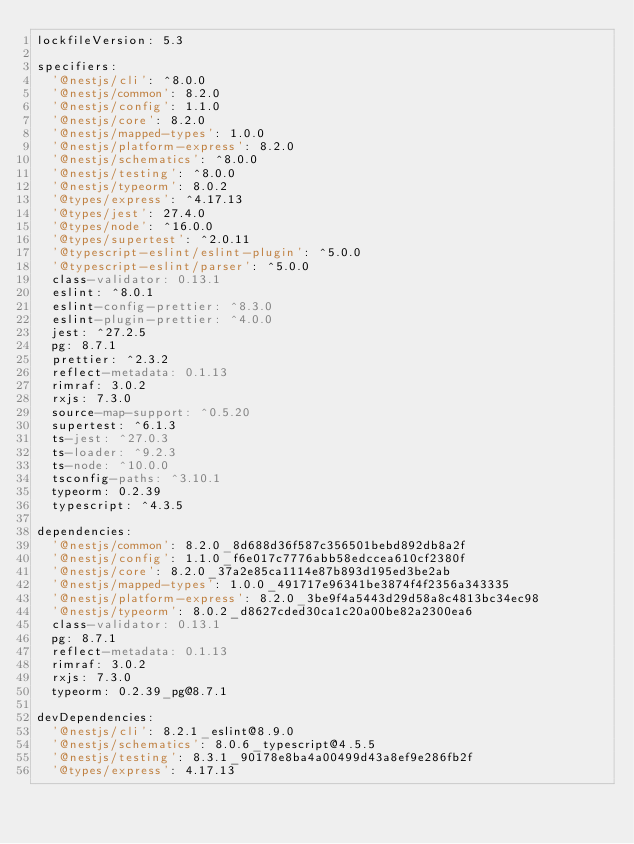<code> <loc_0><loc_0><loc_500><loc_500><_YAML_>lockfileVersion: 5.3

specifiers:
  '@nestjs/cli': ^8.0.0
  '@nestjs/common': 8.2.0
  '@nestjs/config': 1.1.0
  '@nestjs/core': 8.2.0
  '@nestjs/mapped-types': 1.0.0
  '@nestjs/platform-express': 8.2.0
  '@nestjs/schematics': ^8.0.0
  '@nestjs/testing': ^8.0.0
  '@nestjs/typeorm': 8.0.2
  '@types/express': ^4.17.13
  '@types/jest': 27.4.0
  '@types/node': ^16.0.0
  '@types/supertest': ^2.0.11
  '@typescript-eslint/eslint-plugin': ^5.0.0
  '@typescript-eslint/parser': ^5.0.0
  class-validator: 0.13.1
  eslint: ^8.0.1
  eslint-config-prettier: ^8.3.0
  eslint-plugin-prettier: ^4.0.0
  jest: ^27.2.5
  pg: 8.7.1
  prettier: ^2.3.2
  reflect-metadata: 0.1.13
  rimraf: 3.0.2
  rxjs: 7.3.0
  source-map-support: ^0.5.20
  supertest: ^6.1.3
  ts-jest: ^27.0.3
  ts-loader: ^9.2.3
  ts-node: ^10.0.0
  tsconfig-paths: ^3.10.1
  typeorm: 0.2.39
  typescript: ^4.3.5

dependencies:
  '@nestjs/common': 8.2.0_8d688d36f587c356501bebd892db8a2f
  '@nestjs/config': 1.1.0_f6e017c7776abb58edccea610cf2380f
  '@nestjs/core': 8.2.0_37a2e85ca1114e87b893d195ed3be2ab
  '@nestjs/mapped-types': 1.0.0_491717e96341be3874f4f2356a343335
  '@nestjs/platform-express': 8.2.0_3be9f4a5443d29d58a8c4813bc34ec98
  '@nestjs/typeorm': 8.0.2_d8627cded30ca1c20a00be82a2300ea6
  class-validator: 0.13.1
  pg: 8.7.1
  reflect-metadata: 0.1.13
  rimraf: 3.0.2
  rxjs: 7.3.0
  typeorm: 0.2.39_pg@8.7.1

devDependencies:
  '@nestjs/cli': 8.2.1_eslint@8.9.0
  '@nestjs/schematics': 8.0.6_typescript@4.5.5
  '@nestjs/testing': 8.3.1_90178e8ba4a00499d43a8ef9e286fb2f
  '@types/express': 4.17.13</code> 